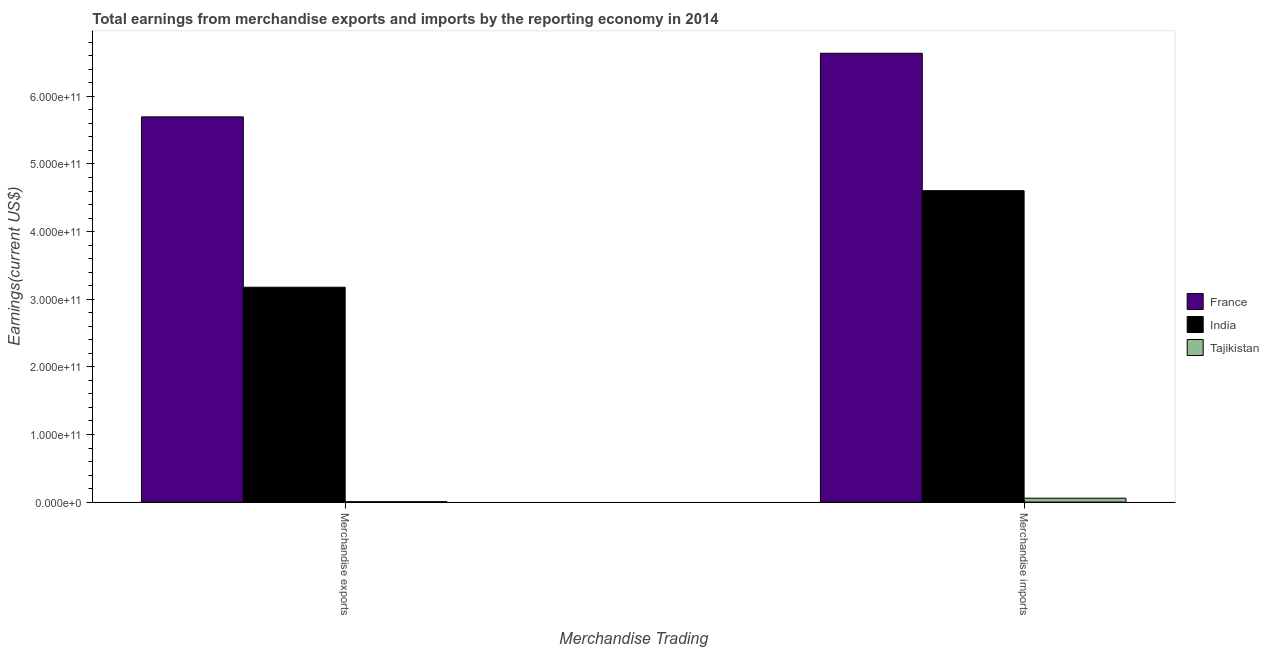Are the number of bars per tick equal to the number of legend labels?
Your answer should be very brief. Yes. Are the number of bars on each tick of the X-axis equal?
Your answer should be compact. Yes. What is the earnings from merchandise exports in Tajikistan?
Make the answer very short. 6.30e+08. Across all countries, what is the maximum earnings from merchandise imports?
Make the answer very short. 6.64e+11. Across all countries, what is the minimum earnings from merchandise exports?
Provide a short and direct response. 6.30e+08. In which country was the earnings from merchandise exports maximum?
Keep it short and to the point. France. In which country was the earnings from merchandise exports minimum?
Offer a very short reply. Tajikistan. What is the total earnings from merchandise imports in the graph?
Provide a short and direct response. 1.13e+12. What is the difference between the earnings from merchandise imports in India and that in Tajikistan?
Provide a short and direct response. 4.55e+11. What is the difference between the earnings from merchandise exports in India and the earnings from merchandise imports in Tajikistan?
Your answer should be compact. 3.12e+11. What is the average earnings from merchandise exports per country?
Give a very brief answer. 2.96e+11. What is the difference between the earnings from merchandise imports and earnings from merchandise exports in India?
Provide a short and direct response. 1.43e+11. What is the ratio of the earnings from merchandise exports in France to that in Tajikistan?
Give a very brief answer. 904.79. Is the earnings from merchandise imports in Tajikistan less than that in India?
Keep it short and to the point. Yes. What does the 3rd bar from the left in Merchandise exports represents?
Offer a very short reply. Tajikistan. How many bars are there?
Provide a succinct answer. 6. How many countries are there in the graph?
Offer a terse response. 3. What is the difference between two consecutive major ticks on the Y-axis?
Your answer should be compact. 1.00e+11. Are the values on the major ticks of Y-axis written in scientific E-notation?
Ensure brevity in your answer.  Yes. How many legend labels are there?
Offer a terse response. 3. How are the legend labels stacked?
Offer a very short reply. Vertical. What is the title of the graph?
Your answer should be very brief. Total earnings from merchandise exports and imports by the reporting economy in 2014. Does "Europe(developing only)" appear as one of the legend labels in the graph?
Give a very brief answer. No. What is the label or title of the X-axis?
Offer a very short reply. Merchandise Trading. What is the label or title of the Y-axis?
Offer a terse response. Earnings(current US$). What is the Earnings(current US$) in France in Merchandise exports?
Provide a succinct answer. 5.70e+11. What is the Earnings(current US$) of India in Merchandise exports?
Provide a succinct answer. 3.18e+11. What is the Earnings(current US$) of Tajikistan in Merchandise exports?
Give a very brief answer. 6.30e+08. What is the Earnings(current US$) in France in Merchandise imports?
Keep it short and to the point. 6.64e+11. What is the Earnings(current US$) of India in Merchandise imports?
Keep it short and to the point. 4.61e+11. What is the Earnings(current US$) of Tajikistan in Merchandise imports?
Your response must be concise. 5.84e+09. Across all Merchandise Trading, what is the maximum Earnings(current US$) in France?
Give a very brief answer. 6.64e+11. Across all Merchandise Trading, what is the maximum Earnings(current US$) of India?
Your response must be concise. 4.61e+11. Across all Merchandise Trading, what is the maximum Earnings(current US$) of Tajikistan?
Offer a very short reply. 5.84e+09. Across all Merchandise Trading, what is the minimum Earnings(current US$) in France?
Ensure brevity in your answer.  5.70e+11. Across all Merchandise Trading, what is the minimum Earnings(current US$) in India?
Your answer should be very brief. 3.18e+11. Across all Merchandise Trading, what is the minimum Earnings(current US$) in Tajikistan?
Ensure brevity in your answer.  6.30e+08. What is the total Earnings(current US$) in France in the graph?
Keep it short and to the point. 1.23e+12. What is the total Earnings(current US$) of India in the graph?
Your answer should be compact. 7.78e+11. What is the total Earnings(current US$) of Tajikistan in the graph?
Make the answer very short. 6.46e+09. What is the difference between the Earnings(current US$) in France in Merchandise exports and that in Merchandise imports?
Offer a terse response. -9.40e+1. What is the difference between the Earnings(current US$) in India in Merchandise exports and that in Merchandise imports?
Your answer should be very brief. -1.43e+11. What is the difference between the Earnings(current US$) in Tajikistan in Merchandise exports and that in Merchandise imports?
Offer a very short reply. -5.21e+09. What is the difference between the Earnings(current US$) in France in Merchandise exports and the Earnings(current US$) in India in Merchandise imports?
Offer a very short reply. 1.09e+11. What is the difference between the Earnings(current US$) in France in Merchandise exports and the Earnings(current US$) in Tajikistan in Merchandise imports?
Give a very brief answer. 5.64e+11. What is the difference between the Earnings(current US$) of India in Merchandise exports and the Earnings(current US$) of Tajikistan in Merchandise imports?
Your answer should be very brief. 3.12e+11. What is the average Earnings(current US$) of France per Merchandise Trading?
Provide a succinct answer. 6.17e+11. What is the average Earnings(current US$) of India per Merchandise Trading?
Your answer should be compact. 3.89e+11. What is the average Earnings(current US$) in Tajikistan per Merchandise Trading?
Ensure brevity in your answer.  3.23e+09. What is the difference between the Earnings(current US$) in France and Earnings(current US$) in India in Merchandise exports?
Provide a succinct answer. 2.52e+11. What is the difference between the Earnings(current US$) of France and Earnings(current US$) of Tajikistan in Merchandise exports?
Your response must be concise. 5.69e+11. What is the difference between the Earnings(current US$) in India and Earnings(current US$) in Tajikistan in Merchandise exports?
Make the answer very short. 3.17e+11. What is the difference between the Earnings(current US$) in France and Earnings(current US$) in India in Merchandise imports?
Provide a succinct answer. 2.03e+11. What is the difference between the Earnings(current US$) of France and Earnings(current US$) of Tajikistan in Merchandise imports?
Make the answer very short. 6.58e+11. What is the difference between the Earnings(current US$) in India and Earnings(current US$) in Tajikistan in Merchandise imports?
Make the answer very short. 4.55e+11. What is the ratio of the Earnings(current US$) of France in Merchandise exports to that in Merchandise imports?
Provide a short and direct response. 0.86. What is the ratio of the Earnings(current US$) of India in Merchandise exports to that in Merchandise imports?
Your response must be concise. 0.69. What is the ratio of the Earnings(current US$) of Tajikistan in Merchandise exports to that in Merchandise imports?
Your answer should be very brief. 0.11. What is the difference between the highest and the second highest Earnings(current US$) of France?
Your answer should be very brief. 9.40e+1. What is the difference between the highest and the second highest Earnings(current US$) in India?
Offer a very short reply. 1.43e+11. What is the difference between the highest and the second highest Earnings(current US$) of Tajikistan?
Keep it short and to the point. 5.21e+09. What is the difference between the highest and the lowest Earnings(current US$) of France?
Your answer should be compact. 9.40e+1. What is the difference between the highest and the lowest Earnings(current US$) in India?
Keep it short and to the point. 1.43e+11. What is the difference between the highest and the lowest Earnings(current US$) in Tajikistan?
Your answer should be compact. 5.21e+09. 